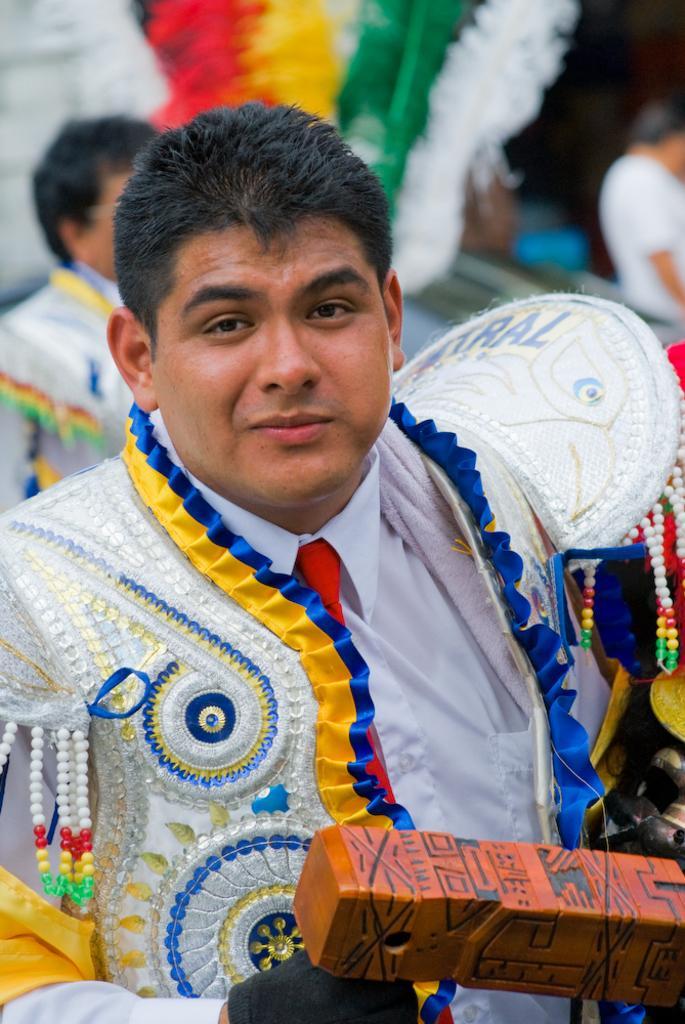How would you summarize this image in a sentence or two? In this image there is a man in the middle who is wearing a costume on which there is some design. In the background there are feathers of different colours. At the bottom the man is holding a wooden piece. 